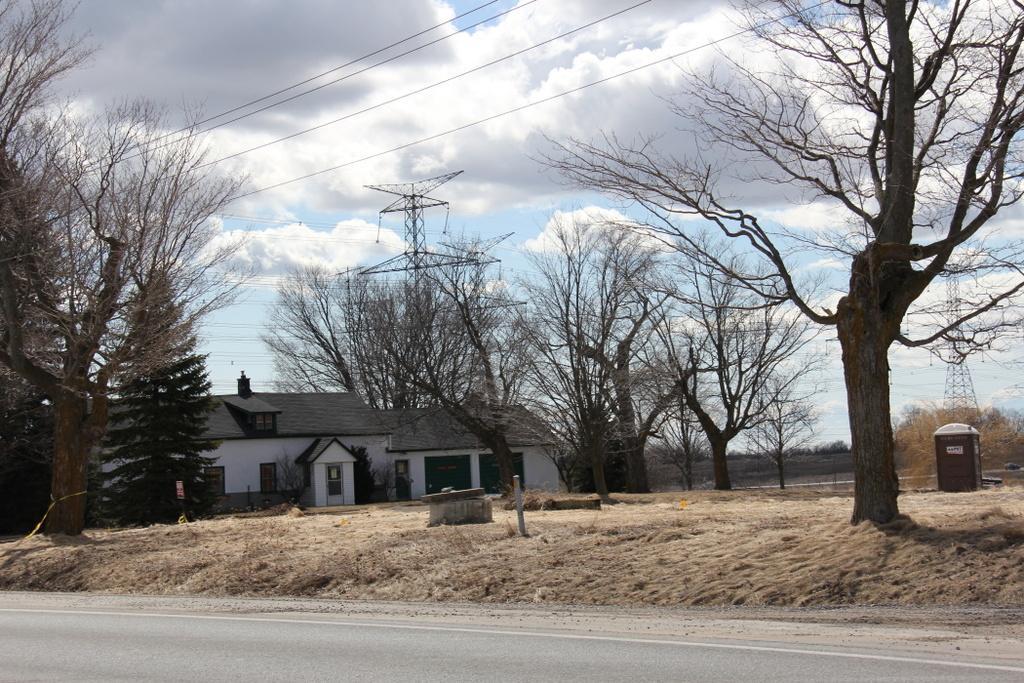In one or two sentences, can you explain what this image depicts? In this image I can see a building in white and gray color. Background I can see dried trees, few electric poles and sky is in white and blue color. 